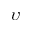Convert formula to latex. <formula><loc_0><loc_0><loc_500><loc_500>\upsilon</formula> 